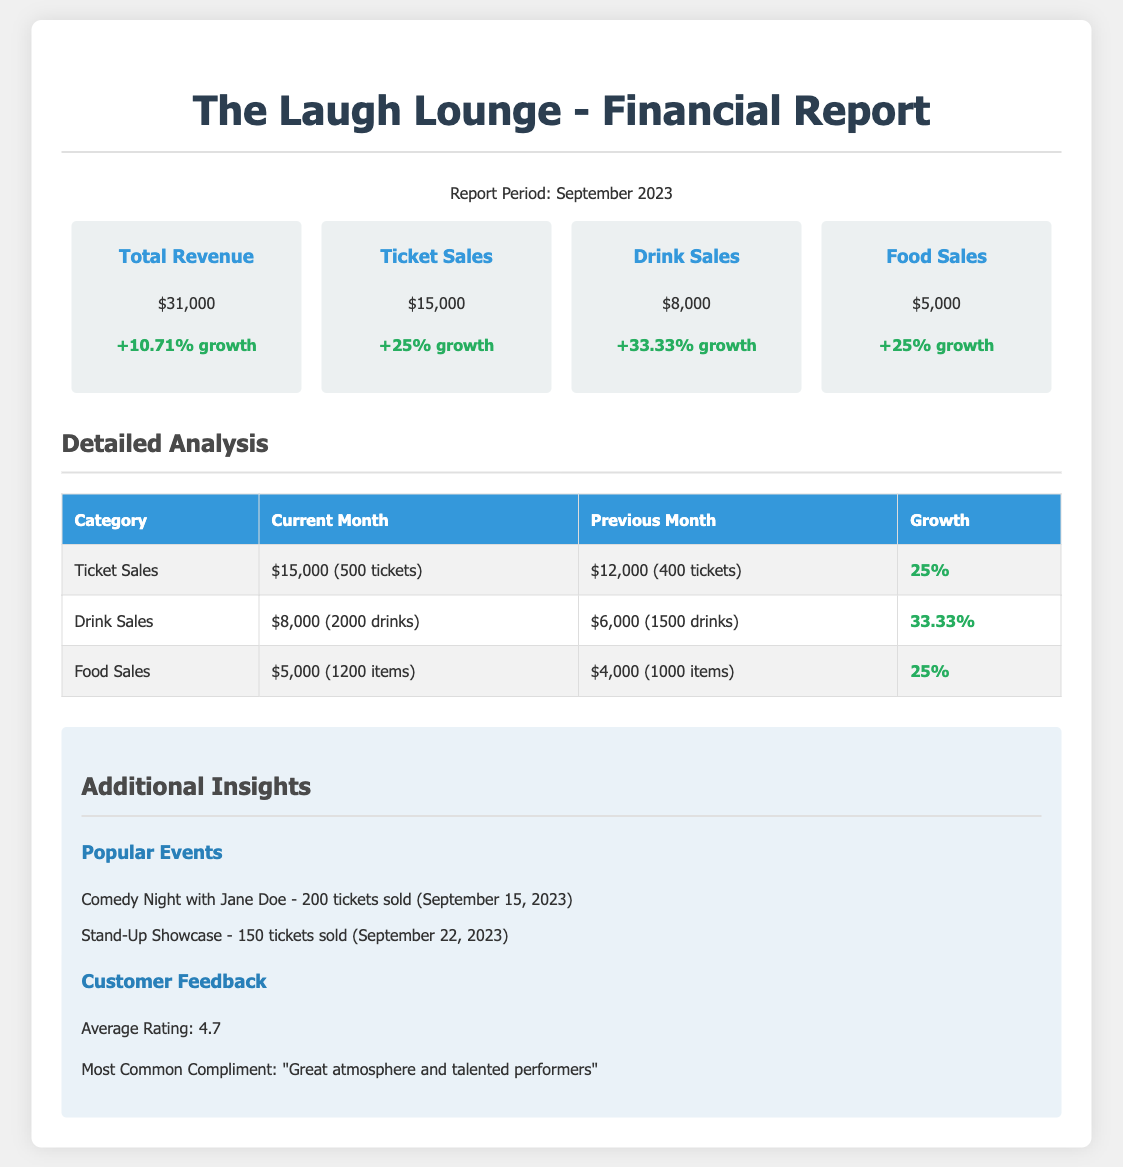What is the total revenue for September 2023? The total revenue is the combined amount from ticket sales, drink sales, and food sales, which totals $31,000.
Answer: $31,000 How much was earned from ticket sales? The document specifies that ticket sales generated $15,000 in revenue for September.
Answer: $15,000 What is the growth percentage of drink sales? The document indicates that drink sales saw a growth of 33.33% compared to the previous month.
Answer: 33.33% How many tickets were sold in the current month? The number of tickets sold in September 2023 is stated as 500 tickets in the detailed analysis.
Answer: 500 tickets What was the food sales revenue in the previous month? The previous month's food sales revenue was $4,000 as indicated in the table.
Answer: $4,000 Which event sold the most tickets in September? The event with the highest ticket sales was "Comedy Night with Jane Doe," selling 200 tickets.
Answer: Comedy Night with Jane Doe What was the average customer rating? The average customer rating provided in the document is 4.7.
Answer: 4.7 How many drinks were sold compared to the previous month? The current month saw 2,000 drinks sold compared to 1,500 drinks sold in the previous month, indicating an increase.
Answer: 2,000 drinks What is the total revenue from food sales? Food sales generated a total of $5,000 for the month of September as shown in the summary.
Answer: $5,000 